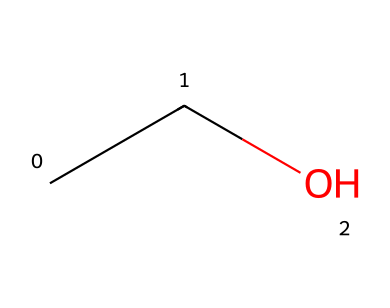What is the name of this compound? The SMILES representation "CCO" corresponds to ethanol, which is a common name for this chemical. The structure indicates that it consists of two carbon atoms (C) and one oxygen atom (O) within the functional group.
Answer: ethanol How many carbon atoms are present in ethanol? Analyzing the SMILES "CCO", we see two "C" letters, which represent carbon atoms. Therefore, there are two carbon atoms present in the structure of ethanol.
Answer: 2 What type of bonding is present in ethanol? The chemical structure indicated by the SMILES shows single bonds between carbon and carbon, as well as between carbon and oxygen. This type of bonding is characteristic of aliphatic compounds, where the carbon atoms are connected mainly by single bonds.
Answer: single What functional group is present in ethanol? The structure described by "CCO" reveals that the oxygen atom is connected to the carbon chain, indicating the presence of a hydroxyl functional group (-OH), which is typical for alcohols like ethanol.
Answer: hydroxyl Is ethanol an aliphatic or aromatic compound? Since the structure "CCO" has a straight-chain of carbon atoms without any cyclic arrangements or double bonds typical of aromatic compounds, this confirms that ethanol is classified as an aliphatic compound.
Answer: aliphatic What is the total number of atoms in ethanol? The SMILES "CCO" includes 2 carbon atoms (C), 6 hydrogen atoms (H, implied by the structure), and 1 oxygen atom (O), leading to a total of 9 atoms. The count is calculated by considering the number of each type of atom present in the structure.
Answer: 9 How many hydrogen atoms are bonded to the carbon atoms in ethanol? The chemical structure indicated by "CCO" allows us to observe that each carbon atom is generally bonded to enough hydrogen atoms to satisfy carbon's tetravalency. Therefore, in this case, 6 hydrogen atoms are present, bonding with the two carbon atoms while still allowing the alcohol functional group to stay attached.
Answer: 6 